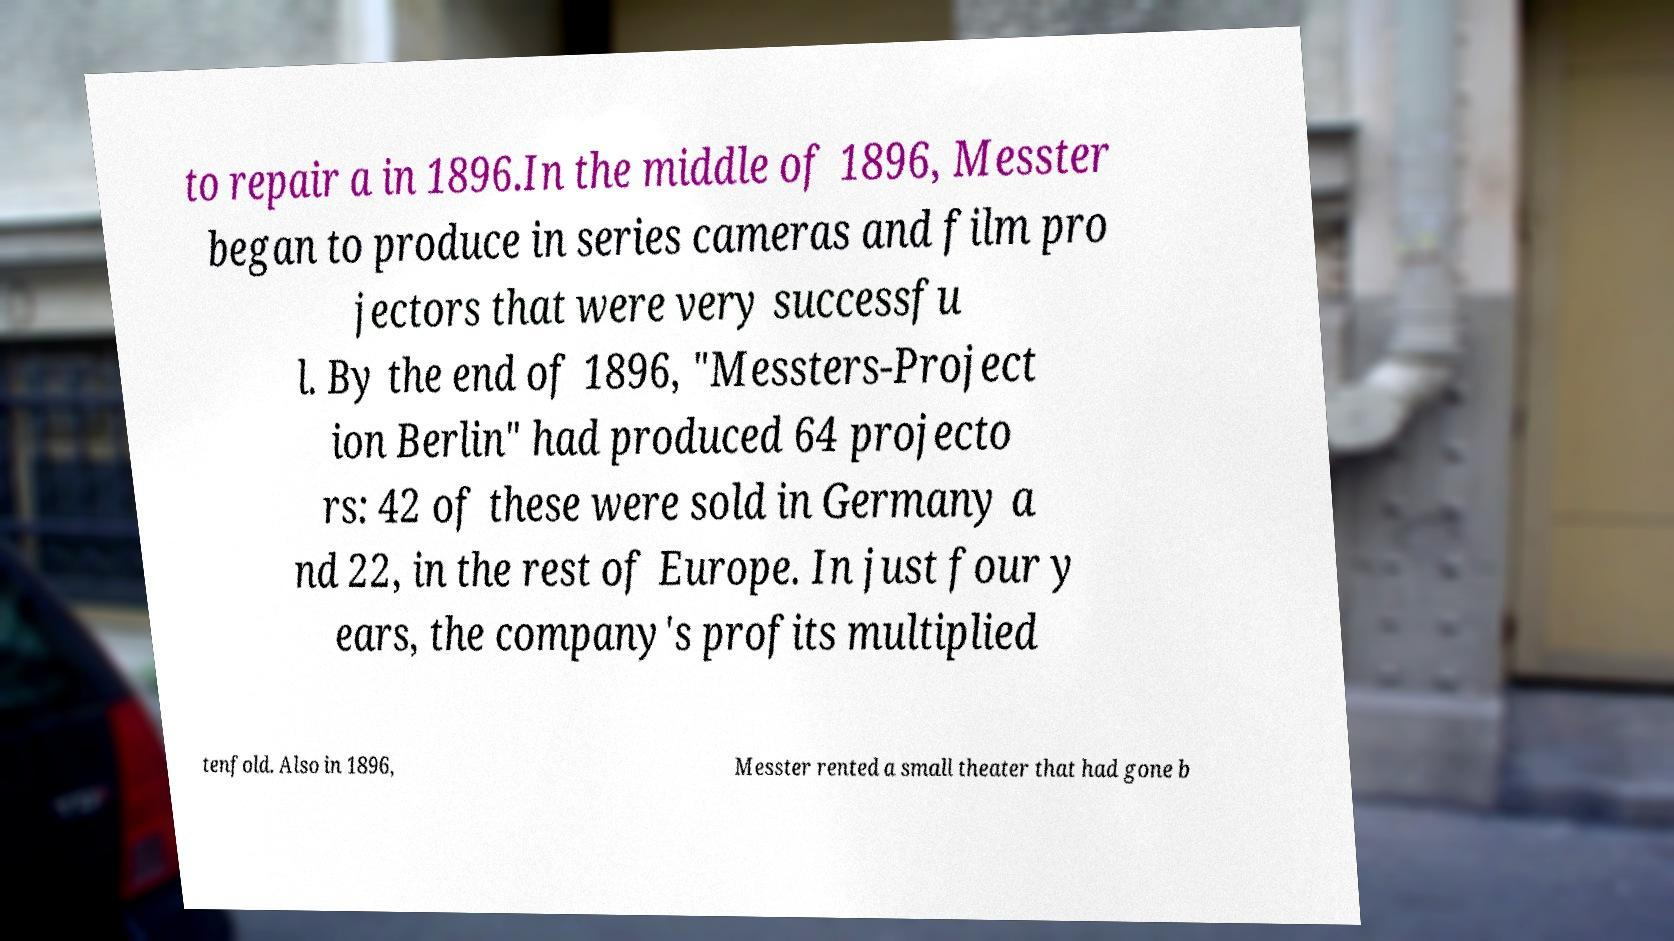Please identify and transcribe the text found in this image. to repair a in 1896.In the middle of 1896, Messter began to produce in series cameras and film pro jectors that were very successfu l. By the end of 1896, "Messters-Project ion Berlin" had produced 64 projecto rs: 42 of these were sold in Germany a nd 22, in the rest of Europe. In just four y ears, the company's profits multiplied tenfold. Also in 1896, Messter rented a small theater that had gone b 